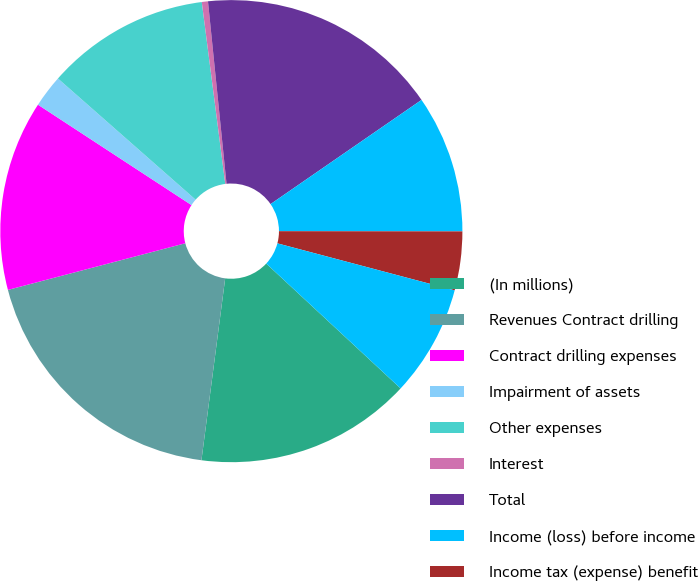Convert chart. <chart><loc_0><loc_0><loc_500><loc_500><pie_chart><fcel>(In millions)<fcel>Revenues Contract drilling<fcel>Contract drilling expenses<fcel>Impairment of assets<fcel>Other expenses<fcel>Interest<fcel>Total<fcel>Income (loss) before income<fcel>Income tax (expense) benefit<fcel>Amounts attributable to<nl><fcel>15.15%<fcel>18.84%<fcel>13.31%<fcel>2.27%<fcel>11.47%<fcel>0.43%<fcel>17.0%<fcel>9.63%<fcel>4.11%<fcel>7.79%<nl></chart> 